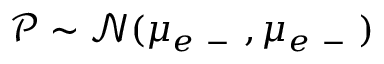<formula> <loc_0><loc_0><loc_500><loc_500>\ m a t h s c r P \sim \mathcal { N } ( \mu _ { e - } , \mu _ { e - } )</formula> 